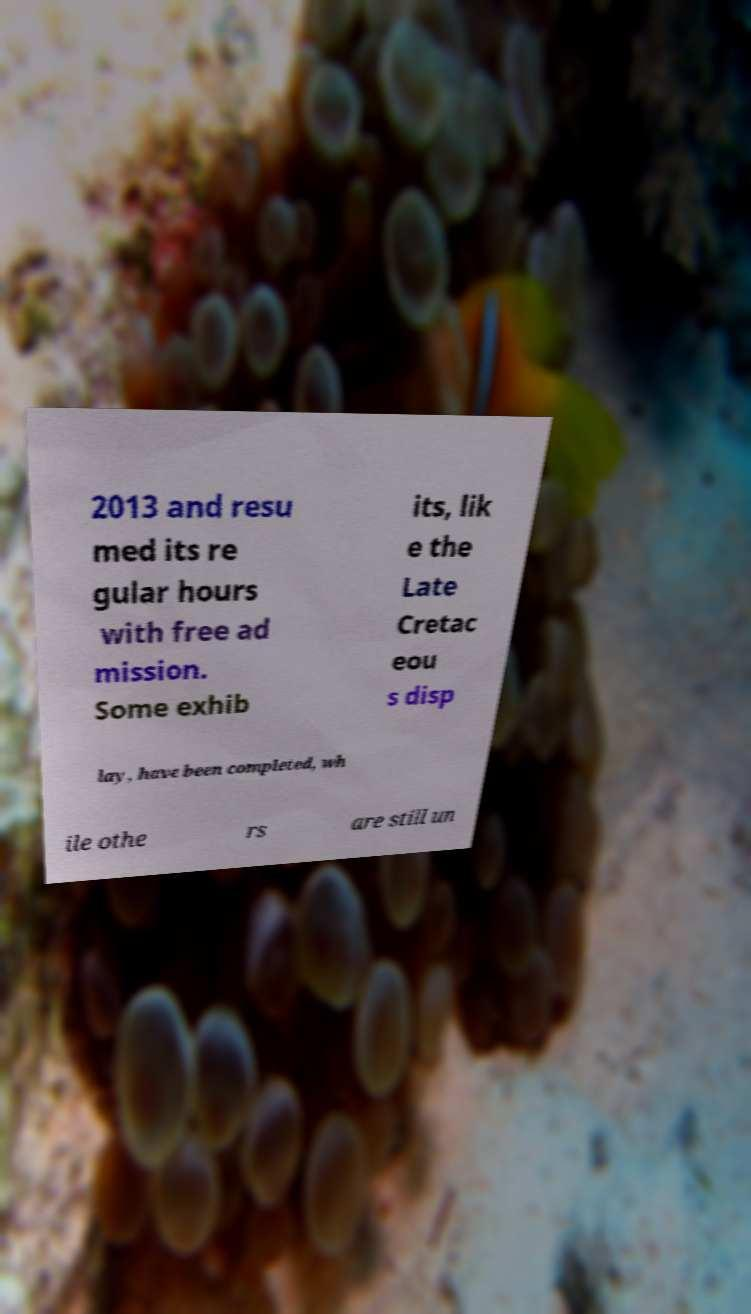What messages or text are displayed in this image? I need them in a readable, typed format. 2013 and resu med its re gular hours with free ad mission. Some exhib its, lik e the Late Cretac eou s disp lay, have been completed, wh ile othe rs are still un 